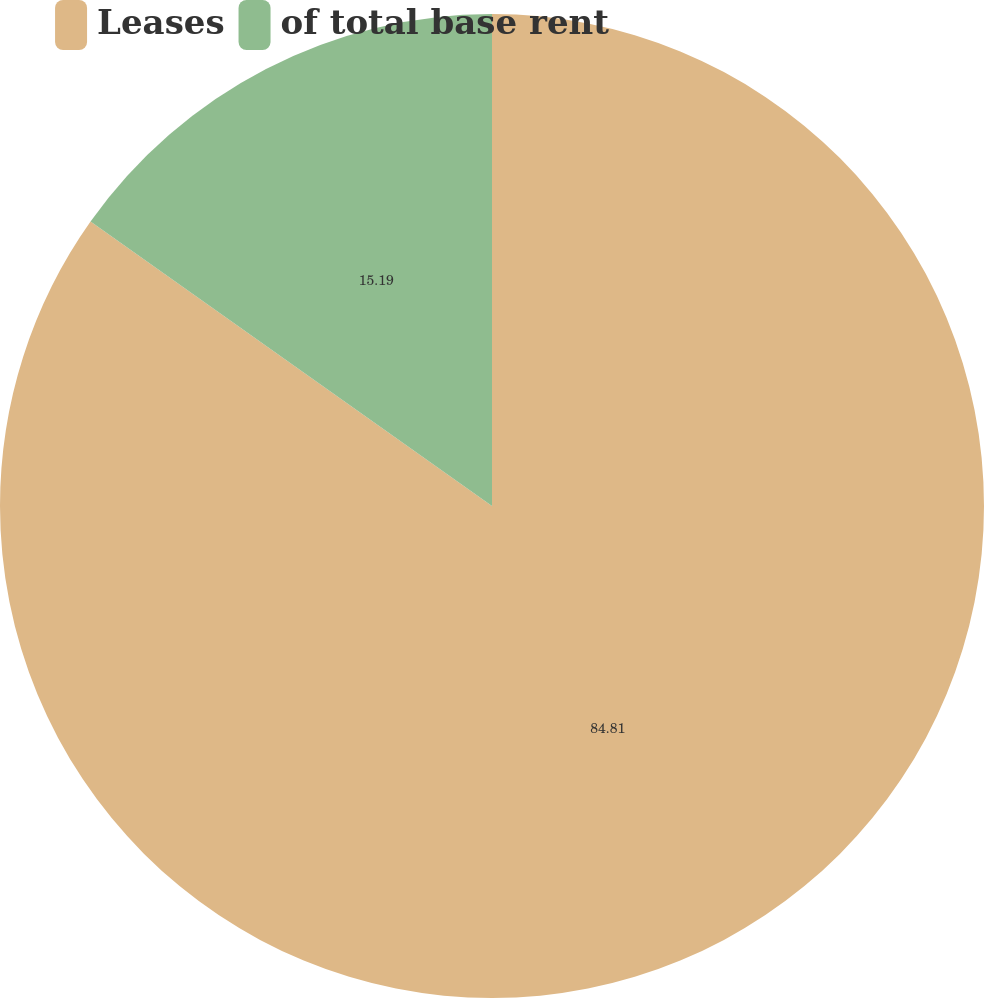Convert chart to OTSL. <chart><loc_0><loc_0><loc_500><loc_500><pie_chart><fcel>Leases<fcel>of total base rent<nl><fcel>84.81%<fcel>15.19%<nl></chart> 